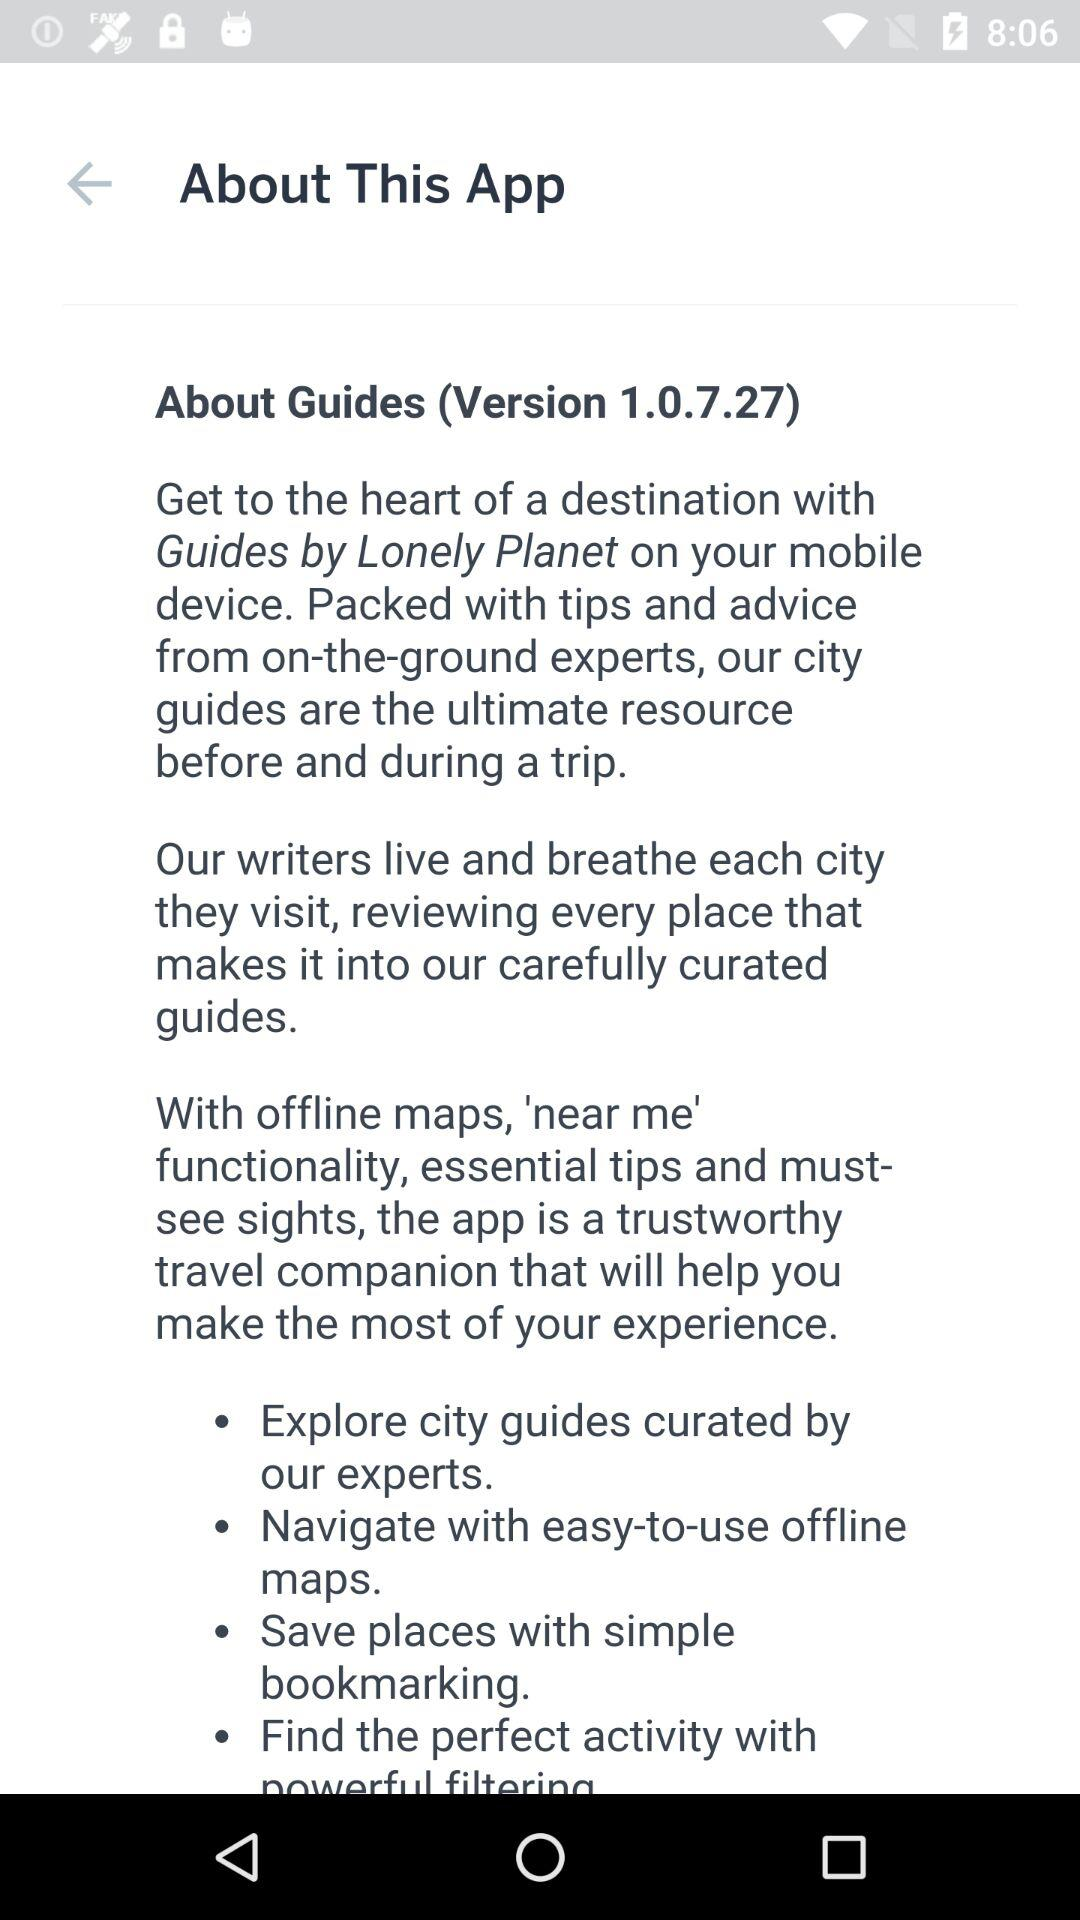What is the version of the application? The version of the application is 1.0.7.27. 